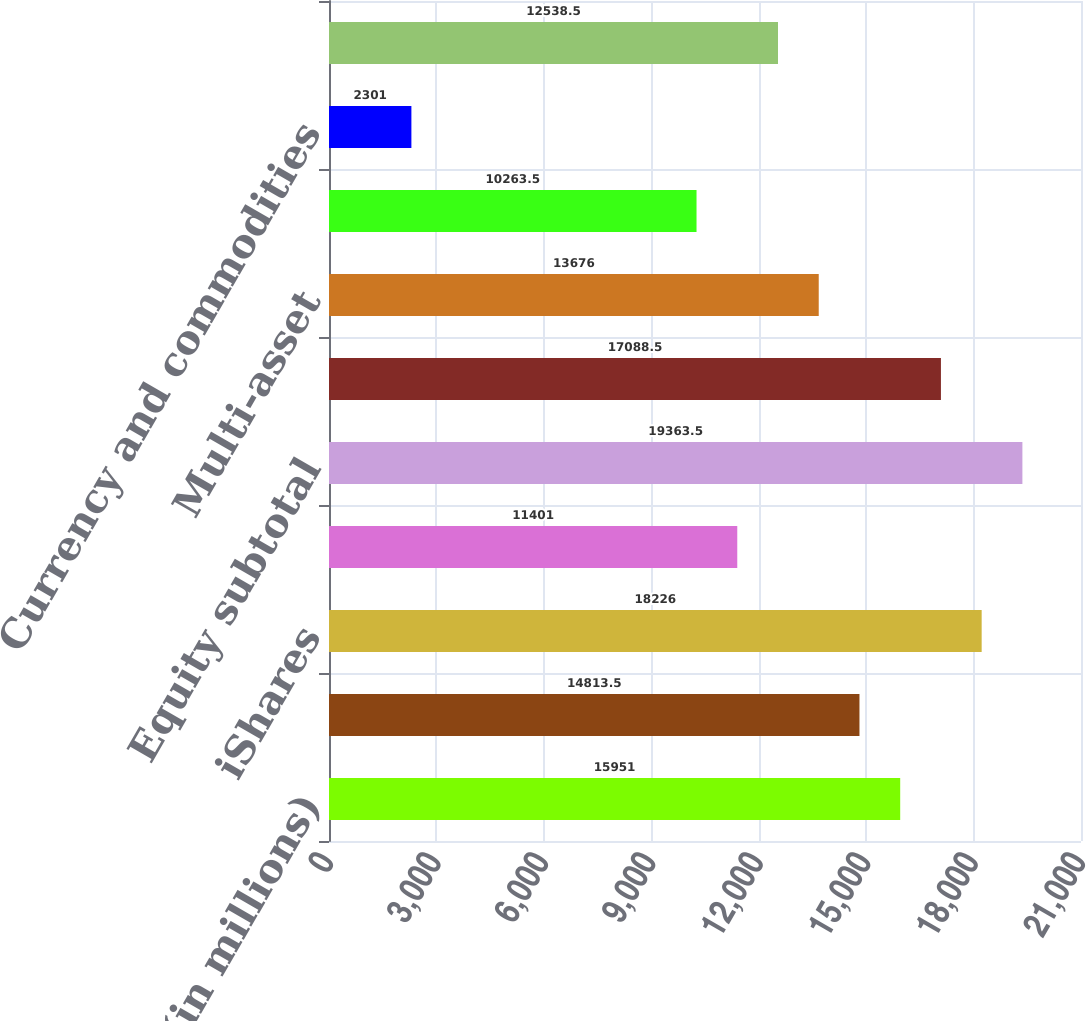<chart> <loc_0><loc_0><loc_500><loc_500><bar_chart><fcel>(in millions)<fcel>Active<fcel>iShares<fcel>Non-ETF index<fcel>Equity subtotal<fcel>Fixed income subtotal<fcel>Multi-asset<fcel>Core<fcel>Currency and commodities<fcel>Alternatives subtotal<nl><fcel>15951<fcel>14813.5<fcel>18226<fcel>11401<fcel>19363.5<fcel>17088.5<fcel>13676<fcel>10263.5<fcel>2301<fcel>12538.5<nl></chart> 